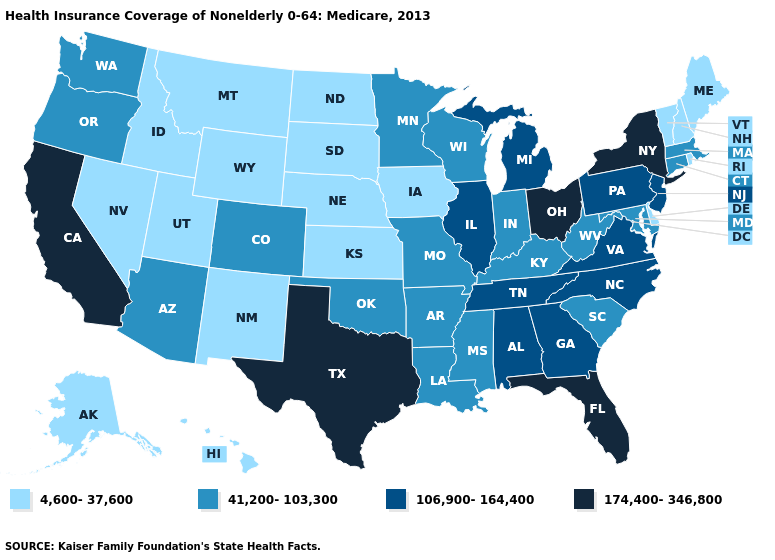What is the value of New Jersey?
Quick response, please. 106,900-164,400. How many symbols are there in the legend?
Write a very short answer. 4. What is the value of Arizona?
Answer briefly. 41,200-103,300. What is the value of Arizona?
Concise answer only. 41,200-103,300. Does West Virginia have the same value as South Carolina?
Give a very brief answer. Yes. Does Texas have the highest value in the USA?
Answer briefly. Yes. What is the lowest value in the Northeast?
Quick response, please. 4,600-37,600. Is the legend a continuous bar?
Keep it brief. No. What is the value of North Carolina?
Be succinct. 106,900-164,400. What is the value of New York?
Keep it brief. 174,400-346,800. Which states have the highest value in the USA?
Be succinct. California, Florida, New York, Ohio, Texas. Among the states that border North Dakota , does Montana have the highest value?
Short answer required. No. Among the states that border Michigan , does Wisconsin have the highest value?
Give a very brief answer. No. What is the highest value in the USA?
Be succinct. 174,400-346,800. 